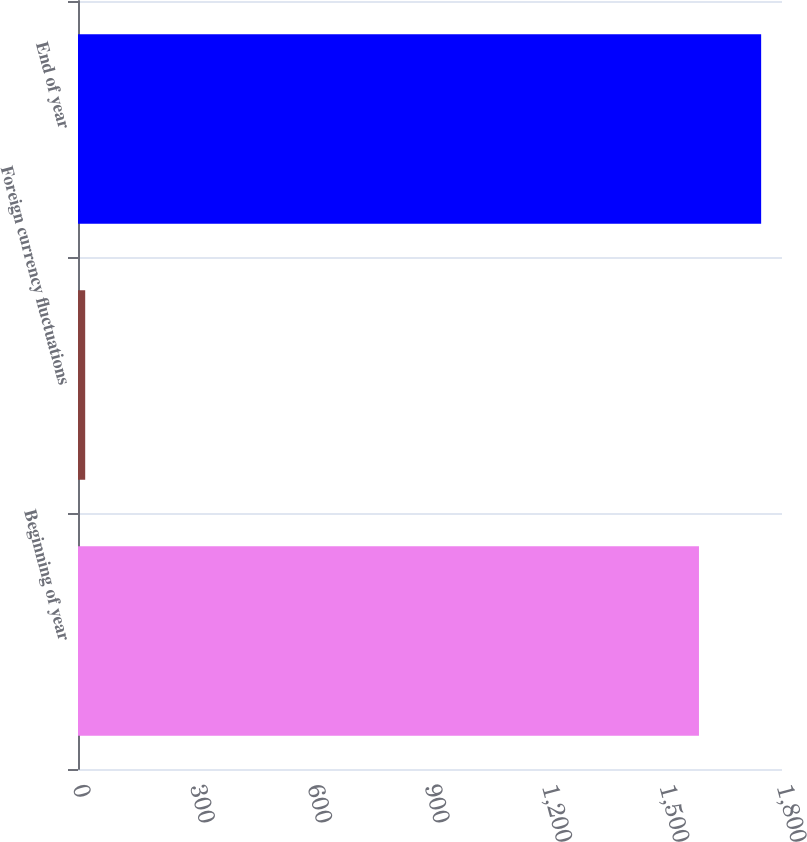<chart> <loc_0><loc_0><loc_500><loc_500><bar_chart><fcel>Beginning of year<fcel>Foreign currency fluctuations<fcel>End of year<nl><fcel>1587.7<fcel>18.4<fcel>1746.69<nl></chart> 